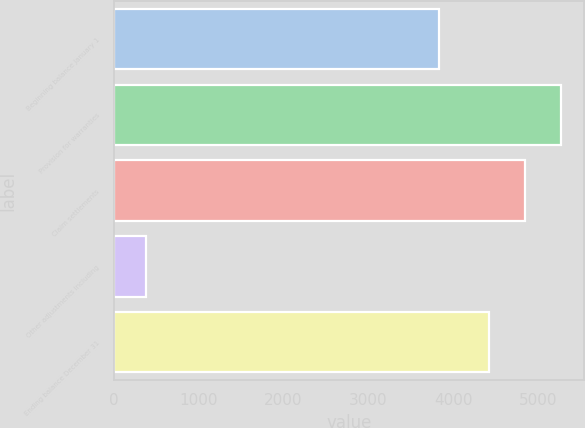Convert chart to OTSL. <chart><loc_0><loc_0><loc_500><loc_500><bar_chart><fcel>Beginning balance January 1<fcel>Provision for warranties<fcel>Claim settlements<fcel>Other adjustments including<fcel>Ending balance December 31<nl><fcel>3831<fcel>5270.4<fcel>4843.7<fcel>381<fcel>4417<nl></chart> 